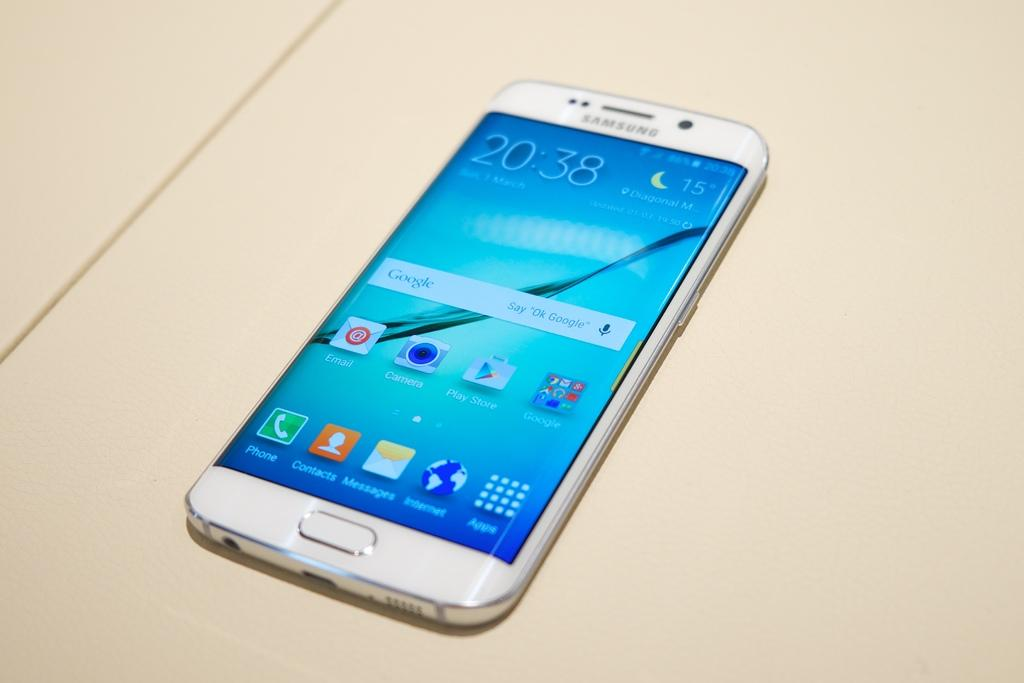<image>
Provide a brief description of the given image. The Samsung phone on the surface shows that it is 15 degrees outside. 